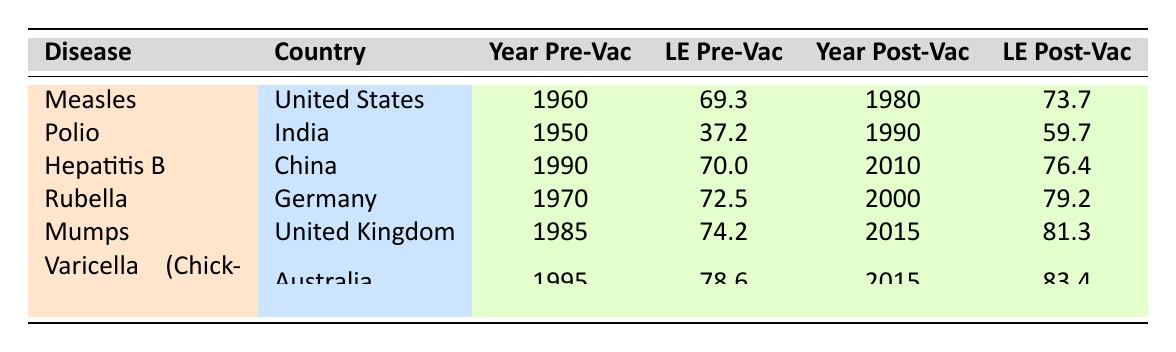What was the life expectancy for Measles in the United States before vaccination? The table shows that the life expectancy pre-vaccination for Measles in the United States was listed as 69.3.
Answer: 69.3 What is the post-vaccination life expectancy for Polio in India? According to the table, the life expectancy post-vaccination for Polio in India is 59.7.
Answer: 59.7 Did the life expectancy for Rubella in Germany increase after vaccination? By comparing the pre-vaccination life expectancy of 72.5 and post-vaccination life expectancy of 79.2, it is evident that there was an increase after vaccination.
Answer: Yes What is the difference in life expectancy for Hepatitis B in China before and after vaccination? The pre-vaccination life expectancy for Hepatitis B was 70.0, and the post-vaccination life expectancy was 76.4. The difference is calculated as 76.4 - 70.0 = 6.4.
Answer: 6.4 Which disease showed the greatest increase in life expectancy post-vaccination? To determine this, we calculate the increases for each disease: Measles (4.4), Polio (22.5), Hepatitis B (6.4), Rubella (6.7), Mumps (7.1), and Varicella (4.8). The largest increase is for Polio with 22.5.
Answer: Polio What year did vaccination campaigns begin for Mumps in the United Kingdom? According to the table, the vaccination campaign for Mumps in the United Kingdom began in 1985.
Answer: 1985 Is the post-vaccination life expectancy for Varicella (Chickenpox) in Australia higher than that for Rubella in Germany? The post-vaccination life expectancy for Varicella is 83.4, while for Rubella it is 79.2. Since 83.4 > 79.2, Varicella’s post-vaccination life expectancy is indeed higher.
Answer: Yes How many years did life expectancy improve for the disease with the least pre-vaccination life expectancy? The disease with the least pre-vaccination life expectancy is Polio at 37.2. Its post-vaccination life expectancy is 59.7, so the improvement is 59.7 - 37.2 = 22.5 years.
Answer: 22.5 